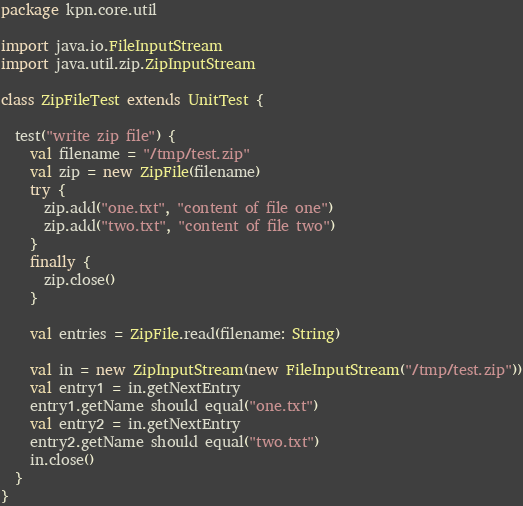<code> <loc_0><loc_0><loc_500><loc_500><_Scala_>package kpn.core.util

import java.io.FileInputStream
import java.util.zip.ZipInputStream

class ZipFileTest extends UnitTest {

  test("write zip file") {
    val filename = "/tmp/test.zip"
    val zip = new ZipFile(filename)
    try {
      zip.add("one.txt", "content of file one")
      zip.add("two.txt", "content of file two")
    }
    finally {
      zip.close()
    }

    val entries = ZipFile.read(filename: String)

    val in = new ZipInputStream(new FileInputStream("/tmp/test.zip"))
    val entry1 = in.getNextEntry
    entry1.getName should equal("one.txt")
    val entry2 = in.getNextEntry
    entry2.getName should equal("two.txt")
    in.close()
  }
}
</code> 